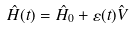<formula> <loc_0><loc_0><loc_500><loc_500>\hat { H } ( t ) = \hat { H } _ { 0 } + \varepsilon ( t ) \hat { V }</formula> 